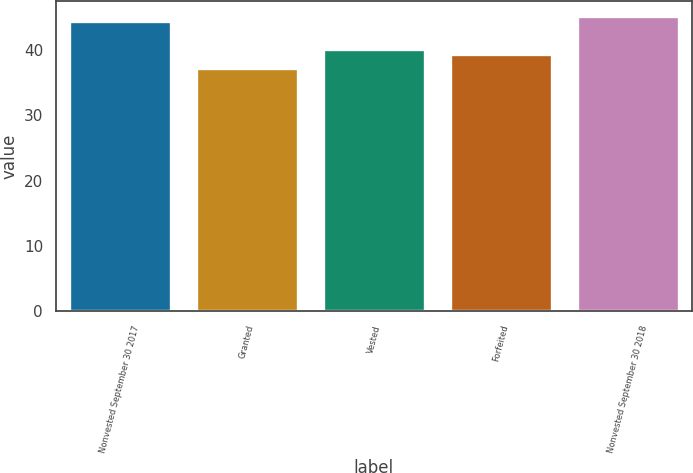Convert chart. <chart><loc_0><loc_0><loc_500><loc_500><bar_chart><fcel>Nonvested September 30 2017<fcel>Granted<fcel>Vested<fcel>Forfeited<fcel>Nonvested September 30 2018<nl><fcel>44.48<fcel>37.21<fcel>40.17<fcel>39.38<fcel>45.27<nl></chart> 